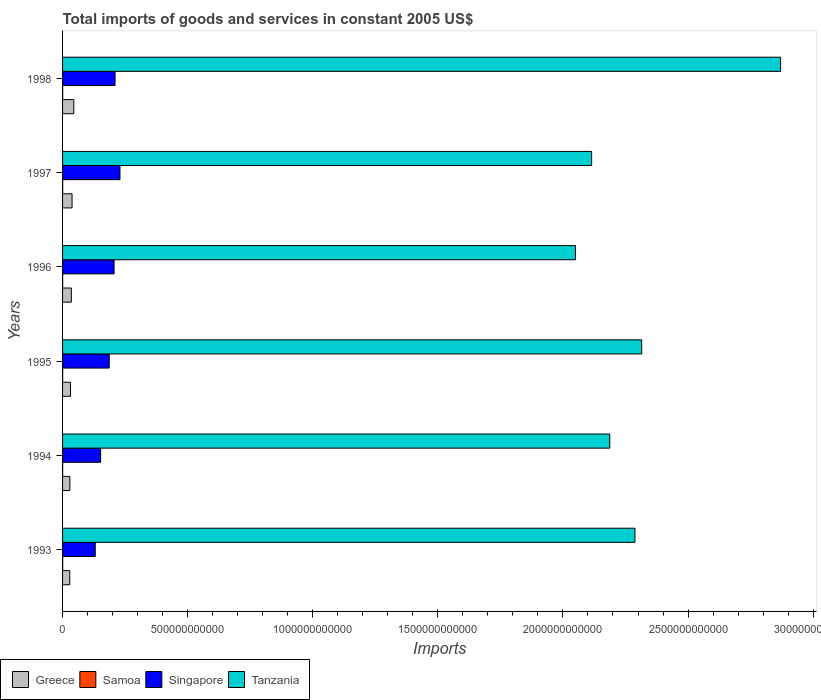How many different coloured bars are there?
Ensure brevity in your answer.  4. How many groups of bars are there?
Ensure brevity in your answer.  6. How many bars are there on the 5th tick from the bottom?
Your answer should be compact. 4. In how many cases, is the number of bars for a given year not equal to the number of legend labels?
Your response must be concise. 0. What is the total imports of goods and services in Greece in 1994?
Your answer should be very brief. 2.92e+1. Across all years, what is the maximum total imports of goods and services in Samoa?
Make the answer very short. 4.44e+08. Across all years, what is the minimum total imports of goods and services in Greece?
Your answer should be compact. 2.88e+1. What is the total total imports of goods and services in Singapore in the graph?
Your answer should be compact. 1.11e+12. What is the difference between the total imports of goods and services in Tanzania in 1993 and that in 1998?
Keep it short and to the point. -5.82e+11. What is the difference between the total imports of goods and services in Tanzania in 1995 and the total imports of goods and services in Greece in 1997?
Make the answer very short. 2.28e+12. What is the average total imports of goods and services in Tanzania per year?
Offer a very short reply. 2.30e+12. In the year 1994, what is the difference between the total imports of goods and services in Samoa and total imports of goods and services in Tanzania?
Your answer should be very brief. -2.19e+12. What is the ratio of the total imports of goods and services in Singapore in 1993 to that in 1996?
Keep it short and to the point. 0.63. Is the total imports of goods and services in Tanzania in 1996 less than that in 1998?
Your answer should be very brief. Yes. What is the difference between the highest and the second highest total imports of goods and services in Greece?
Your answer should be very brief. 6.90e+09. What is the difference between the highest and the lowest total imports of goods and services in Singapore?
Provide a short and direct response. 9.89e+1. In how many years, is the total imports of goods and services in Singapore greater than the average total imports of goods and services in Singapore taken over all years?
Offer a terse response. 4. Is it the case that in every year, the sum of the total imports of goods and services in Samoa and total imports of goods and services in Tanzania is greater than the sum of total imports of goods and services in Greece and total imports of goods and services in Singapore?
Offer a terse response. No. What does the 3rd bar from the bottom in 1995 represents?
Your response must be concise. Singapore. Is it the case that in every year, the sum of the total imports of goods and services in Singapore and total imports of goods and services in Tanzania is greater than the total imports of goods and services in Greece?
Provide a succinct answer. Yes. How many bars are there?
Your response must be concise. 24. How many years are there in the graph?
Your answer should be compact. 6. What is the difference between two consecutive major ticks on the X-axis?
Offer a terse response. 5.00e+11. Does the graph contain any zero values?
Offer a terse response. No. How many legend labels are there?
Provide a short and direct response. 4. How are the legend labels stacked?
Ensure brevity in your answer.  Horizontal. What is the title of the graph?
Offer a terse response. Total imports of goods and services in constant 2005 US$. What is the label or title of the X-axis?
Offer a terse response. Imports. What is the label or title of the Y-axis?
Your answer should be very brief. Years. What is the Imports in Greece in 1993?
Provide a succinct answer. 2.88e+1. What is the Imports in Samoa in 1993?
Keep it short and to the point. 4.41e+08. What is the Imports in Singapore in 1993?
Keep it short and to the point. 1.31e+11. What is the Imports of Tanzania in 1993?
Offer a terse response. 2.29e+12. What is the Imports in Greece in 1994?
Make the answer very short. 2.92e+1. What is the Imports of Samoa in 1994?
Provide a succinct answer. 2.93e+08. What is the Imports of Singapore in 1994?
Offer a terse response. 1.52e+11. What is the Imports of Tanzania in 1994?
Give a very brief answer. 2.19e+12. What is the Imports of Greece in 1995?
Your response must be concise. 3.19e+1. What is the Imports of Samoa in 1995?
Your response must be concise. 3.54e+08. What is the Imports of Singapore in 1995?
Give a very brief answer. 1.87e+11. What is the Imports of Tanzania in 1995?
Your response must be concise. 2.31e+12. What is the Imports in Greece in 1996?
Keep it short and to the point. 3.50e+1. What is the Imports in Samoa in 1996?
Keep it short and to the point. 3.75e+08. What is the Imports in Singapore in 1996?
Make the answer very short. 2.06e+11. What is the Imports of Tanzania in 1996?
Your answer should be compact. 2.05e+12. What is the Imports of Greece in 1997?
Give a very brief answer. 3.80e+1. What is the Imports of Samoa in 1997?
Keep it short and to the point. 3.98e+08. What is the Imports in Singapore in 1997?
Provide a short and direct response. 2.30e+11. What is the Imports in Tanzania in 1997?
Offer a terse response. 2.11e+12. What is the Imports in Greece in 1998?
Give a very brief answer. 4.49e+1. What is the Imports of Samoa in 1998?
Make the answer very short. 4.44e+08. What is the Imports of Singapore in 1998?
Ensure brevity in your answer.  2.10e+11. What is the Imports in Tanzania in 1998?
Your response must be concise. 2.87e+12. Across all years, what is the maximum Imports in Greece?
Offer a very short reply. 4.49e+1. Across all years, what is the maximum Imports in Samoa?
Your answer should be very brief. 4.44e+08. Across all years, what is the maximum Imports of Singapore?
Your response must be concise. 2.30e+11. Across all years, what is the maximum Imports in Tanzania?
Ensure brevity in your answer.  2.87e+12. Across all years, what is the minimum Imports in Greece?
Your answer should be compact. 2.88e+1. Across all years, what is the minimum Imports in Samoa?
Provide a short and direct response. 2.93e+08. Across all years, what is the minimum Imports in Singapore?
Make the answer very short. 1.31e+11. Across all years, what is the minimum Imports of Tanzania?
Give a very brief answer. 2.05e+12. What is the total Imports in Greece in the graph?
Give a very brief answer. 2.08e+11. What is the total Imports in Samoa in the graph?
Ensure brevity in your answer.  2.30e+09. What is the total Imports in Singapore in the graph?
Provide a succinct answer. 1.11e+12. What is the total Imports in Tanzania in the graph?
Your answer should be very brief. 1.38e+13. What is the difference between the Imports in Greece in 1993 and that in 1994?
Offer a very short reply. -4.32e+08. What is the difference between the Imports in Samoa in 1993 and that in 1994?
Keep it short and to the point. 1.48e+08. What is the difference between the Imports of Singapore in 1993 and that in 1994?
Make the answer very short. -2.15e+1. What is the difference between the Imports of Tanzania in 1993 and that in 1994?
Your answer should be very brief. 1.01e+11. What is the difference between the Imports of Greece in 1993 and that in 1995?
Offer a terse response. -3.05e+09. What is the difference between the Imports in Samoa in 1993 and that in 1995?
Give a very brief answer. 8.76e+07. What is the difference between the Imports of Singapore in 1993 and that in 1995?
Keep it short and to the point. -5.59e+1. What is the difference between the Imports of Tanzania in 1993 and that in 1995?
Your answer should be compact. -2.69e+1. What is the difference between the Imports of Greece in 1993 and that in 1996?
Your answer should be compact. -6.21e+09. What is the difference between the Imports of Samoa in 1993 and that in 1996?
Ensure brevity in your answer.  6.65e+07. What is the difference between the Imports of Singapore in 1993 and that in 1996?
Give a very brief answer. -7.53e+1. What is the difference between the Imports of Tanzania in 1993 and that in 1996?
Ensure brevity in your answer.  2.38e+11. What is the difference between the Imports of Greece in 1993 and that in 1997?
Your response must be concise. -9.17e+09. What is the difference between the Imports of Samoa in 1993 and that in 1997?
Make the answer very short. 4.33e+07. What is the difference between the Imports of Singapore in 1993 and that in 1997?
Offer a terse response. -9.89e+1. What is the difference between the Imports of Tanzania in 1993 and that in 1997?
Give a very brief answer. 1.73e+11. What is the difference between the Imports in Greece in 1993 and that in 1998?
Make the answer very short. -1.61e+1. What is the difference between the Imports in Samoa in 1993 and that in 1998?
Offer a terse response. -2.34e+06. What is the difference between the Imports in Singapore in 1993 and that in 1998?
Offer a terse response. -7.92e+1. What is the difference between the Imports of Tanzania in 1993 and that in 1998?
Your answer should be very brief. -5.82e+11. What is the difference between the Imports of Greece in 1994 and that in 1995?
Provide a short and direct response. -2.62e+09. What is the difference between the Imports of Samoa in 1994 and that in 1995?
Provide a succinct answer. -6.03e+07. What is the difference between the Imports of Singapore in 1994 and that in 1995?
Offer a terse response. -3.44e+1. What is the difference between the Imports of Tanzania in 1994 and that in 1995?
Provide a succinct answer. -1.27e+11. What is the difference between the Imports of Greece in 1994 and that in 1996?
Ensure brevity in your answer.  -5.78e+09. What is the difference between the Imports in Samoa in 1994 and that in 1996?
Make the answer very short. -8.14e+07. What is the difference between the Imports of Singapore in 1994 and that in 1996?
Provide a succinct answer. -5.38e+1. What is the difference between the Imports in Tanzania in 1994 and that in 1996?
Provide a succinct answer. 1.37e+11. What is the difference between the Imports of Greece in 1994 and that in 1997?
Offer a terse response. -8.74e+09. What is the difference between the Imports in Samoa in 1994 and that in 1997?
Make the answer very short. -1.05e+08. What is the difference between the Imports of Singapore in 1994 and that in 1997?
Your response must be concise. -7.74e+1. What is the difference between the Imports in Tanzania in 1994 and that in 1997?
Ensure brevity in your answer.  7.25e+1. What is the difference between the Imports in Greece in 1994 and that in 1998?
Offer a terse response. -1.56e+1. What is the difference between the Imports in Samoa in 1994 and that in 1998?
Your answer should be very brief. -1.50e+08. What is the difference between the Imports of Singapore in 1994 and that in 1998?
Provide a succinct answer. -5.77e+1. What is the difference between the Imports of Tanzania in 1994 and that in 1998?
Keep it short and to the point. -6.83e+11. What is the difference between the Imports of Greece in 1995 and that in 1996?
Offer a very short reply. -3.17e+09. What is the difference between the Imports of Samoa in 1995 and that in 1996?
Provide a succinct answer. -2.11e+07. What is the difference between the Imports of Singapore in 1995 and that in 1996?
Your response must be concise. -1.94e+1. What is the difference between the Imports in Tanzania in 1995 and that in 1996?
Provide a succinct answer. 2.65e+11. What is the difference between the Imports of Greece in 1995 and that in 1997?
Offer a very short reply. -6.12e+09. What is the difference between the Imports of Samoa in 1995 and that in 1997?
Your response must be concise. -4.42e+07. What is the difference between the Imports of Singapore in 1995 and that in 1997?
Keep it short and to the point. -4.30e+1. What is the difference between the Imports in Tanzania in 1995 and that in 1997?
Your response must be concise. 2.00e+11. What is the difference between the Imports of Greece in 1995 and that in 1998?
Provide a short and direct response. -1.30e+1. What is the difference between the Imports of Samoa in 1995 and that in 1998?
Offer a terse response. -8.99e+07. What is the difference between the Imports in Singapore in 1995 and that in 1998?
Make the answer very short. -2.33e+1. What is the difference between the Imports in Tanzania in 1995 and that in 1998?
Keep it short and to the point. -5.55e+11. What is the difference between the Imports in Greece in 1996 and that in 1997?
Offer a terse response. -2.96e+09. What is the difference between the Imports in Samoa in 1996 and that in 1997?
Offer a terse response. -2.32e+07. What is the difference between the Imports in Singapore in 1996 and that in 1997?
Offer a very short reply. -2.36e+1. What is the difference between the Imports of Tanzania in 1996 and that in 1997?
Provide a short and direct response. -6.46e+1. What is the difference between the Imports in Greece in 1996 and that in 1998?
Your answer should be compact. -9.85e+09. What is the difference between the Imports of Samoa in 1996 and that in 1998?
Your answer should be very brief. -6.88e+07. What is the difference between the Imports of Singapore in 1996 and that in 1998?
Ensure brevity in your answer.  -3.88e+09. What is the difference between the Imports of Tanzania in 1996 and that in 1998?
Ensure brevity in your answer.  -8.20e+11. What is the difference between the Imports of Greece in 1997 and that in 1998?
Provide a short and direct response. -6.90e+09. What is the difference between the Imports of Samoa in 1997 and that in 1998?
Give a very brief answer. -4.57e+07. What is the difference between the Imports of Singapore in 1997 and that in 1998?
Your answer should be very brief. 1.97e+1. What is the difference between the Imports of Tanzania in 1997 and that in 1998?
Ensure brevity in your answer.  -7.55e+11. What is the difference between the Imports in Greece in 1993 and the Imports in Samoa in 1994?
Offer a terse response. 2.85e+1. What is the difference between the Imports in Greece in 1993 and the Imports in Singapore in 1994?
Provide a succinct answer. -1.23e+11. What is the difference between the Imports in Greece in 1993 and the Imports in Tanzania in 1994?
Your answer should be very brief. -2.16e+12. What is the difference between the Imports in Samoa in 1993 and the Imports in Singapore in 1994?
Make the answer very short. -1.52e+11. What is the difference between the Imports of Samoa in 1993 and the Imports of Tanzania in 1994?
Your response must be concise. -2.19e+12. What is the difference between the Imports in Singapore in 1993 and the Imports in Tanzania in 1994?
Make the answer very short. -2.06e+12. What is the difference between the Imports in Greece in 1993 and the Imports in Samoa in 1995?
Make the answer very short. 2.85e+1. What is the difference between the Imports in Greece in 1993 and the Imports in Singapore in 1995?
Give a very brief answer. -1.58e+11. What is the difference between the Imports in Greece in 1993 and the Imports in Tanzania in 1995?
Make the answer very short. -2.29e+12. What is the difference between the Imports of Samoa in 1993 and the Imports of Singapore in 1995?
Offer a very short reply. -1.86e+11. What is the difference between the Imports in Samoa in 1993 and the Imports in Tanzania in 1995?
Your response must be concise. -2.31e+12. What is the difference between the Imports of Singapore in 1993 and the Imports of Tanzania in 1995?
Your answer should be compact. -2.18e+12. What is the difference between the Imports of Greece in 1993 and the Imports of Samoa in 1996?
Provide a short and direct response. 2.84e+1. What is the difference between the Imports in Greece in 1993 and the Imports in Singapore in 1996?
Ensure brevity in your answer.  -1.77e+11. What is the difference between the Imports in Greece in 1993 and the Imports in Tanzania in 1996?
Ensure brevity in your answer.  -2.02e+12. What is the difference between the Imports of Samoa in 1993 and the Imports of Singapore in 1996?
Keep it short and to the point. -2.06e+11. What is the difference between the Imports in Samoa in 1993 and the Imports in Tanzania in 1996?
Keep it short and to the point. -2.05e+12. What is the difference between the Imports of Singapore in 1993 and the Imports of Tanzania in 1996?
Offer a very short reply. -1.92e+12. What is the difference between the Imports of Greece in 1993 and the Imports of Samoa in 1997?
Make the answer very short. 2.84e+1. What is the difference between the Imports of Greece in 1993 and the Imports of Singapore in 1997?
Provide a short and direct response. -2.01e+11. What is the difference between the Imports in Greece in 1993 and the Imports in Tanzania in 1997?
Provide a succinct answer. -2.09e+12. What is the difference between the Imports in Samoa in 1993 and the Imports in Singapore in 1997?
Ensure brevity in your answer.  -2.29e+11. What is the difference between the Imports of Samoa in 1993 and the Imports of Tanzania in 1997?
Give a very brief answer. -2.11e+12. What is the difference between the Imports of Singapore in 1993 and the Imports of Tanzania in 1997?
Give a very brief answer. -1.98e+12. What is the difference between the Imports of Greece in 1993 and the Imports of Samoa in 1998?
Your answer should be very brief. 2.84e+1. What is the difference between the Imports in Greece in 1993 and the Imports in Singapore in 1998?
Keep it short and to the point. -1.81e+11. What is the difference between the Imports in Greece in 1993 and the Imports in Tanzania in 1998?
Offer a very short reply. -2.84e+12. What is the difference between the Imports of Samoa in 1993 and the Imports of Singapore in 1998?
Offer a very short reply. -2.09e+11. What is the difference between the Imports of Samoa in 1993 and the Imports of Tanzania in 1998?
Ensure brevity in your answer.  -2.87e+12. What is the difference between the Imports in Singapore in 1993 and the Imports in Tanzania in 1998?
Provide a succinct answer. -2.74e+12. What is the difference between the Imports in Greece in 1994 and the Imports in Samoa in 1995?
Your response must be concise. 2.89e+1. What is the difference between the Imports of Greece in 1994 and the Imports of Singapore in 1995?
Offer a terse response. -1.57e+11. What is the difference between the Imports of Greece in 1994 and the Imports of Tanzania in 1995?
Provide a short and direct response. -2.29e+12. What is the difference between the Imports of Samoa in 1994 and the Imports of Singapore in 1995?
Provide a succinct answer. -1.86e+11. What is the difference between the Imports of Samoa in 1994 and the Imports of Tanzania in 1995?
Your response must be concise. -2.31e+12. What is the difference between the Imports in Singapore in 1994 and the Imports in Tanzania in 1995?
Your response must be concise. -2.16e+12. What is the difference between the Imports in Greece in 1994 and the Imports in Samoa in 1996?
Your response must be concise. 2.89e+1. What is the difference between the Imports in Greece in 1994 and the Imports in Singapore in 1996?
Keep it short and to the point. -1.77e+11. What is the difference between the Imports in Greece in 1994 and the Imports in Tanzania in 1996?
Give a very brief answer. -2.02e+12. What is the difference between the Imports in Samoa in 1994 and the Imports in Singapore in 1996?
Keep it short and to the point. -2.06e+11. What is the difference between the Imports of Samoa in 1994 and the Imports of Tanzania in 1996?
Provide a short and direct response. -2.05e+12. What is the difference between the Imports in Singapore in 1994 and the Imports in Tanzania in 1996?
Offer a terse response. -1.90e+12. What is the difference between the Imports of Greece in 1994 and the Imports of Samoa in 1997?
Offer a very short reply. 2.88e+1. What is the difference between the Imports of Greece in 1994 and the Imports of Singapore in 1997?
Provide a succinct answer. -2.00e+11. What is the difference between the Imports of Greece in 1994 and the Imports of Tanzania in 1997?
Offer a very short reply. -2.09e+12. What is the difference between the Imports in Samoa in 1994 and the Imports in Singapore in 1997?
Your response must be concise. -2.29e+11. What is the difference between the Imports of Samoa in 1994 and the Imports of Tanzania in 1997?
Your answer should be compact. -2.11e+12. What is the difference between the Imports of Singapore in 1994 and the Imports of Tanzania in 1997?
Provide a succinct answer. -1.96e+12. What is the difference between the Imports in Greece in 1994 and the Imports in Samoa in 1998?
Give a very brief answer. 2.88e+1. What is the difference between the Imports of Greece in 1994 and the Imports of Singapore in 1998?
Your response must be concise. -1.81e+11. What is the difference between the Imports of Greece in 1994 and the Imports of Tanzania in 1998?
Your response must be concise. -2.84e+12. What is the difference between the Imports in Samoa in 1994 and the Imports in Singapore in 1998?
Ensure brevity in your answer.  -2.10e+11. What is the difference between the Imports in Samoa in 1994 and the Imports in Tanzania in 1998?
Give a very brief answer. -2.87e+12. What is the difference between the Imports in Singapore in 1994 and the Imports in Tanzania in 1998?
Provide a short and direct response. -2.72e+12. What is the difference between the Imports in Greece in 1995 and the Imports in Samoa in 1996?
Your response must be concise. 3.15e+1. What is the difference between the Imports of Greece in 1995 and the Imports of Singapore in 1996?
Offer a terse response. -1.74e+11. What is the difference between the Imports of Greece in 1995 and the Imports of Tanzania in 1996?
Provide a short and direct response. -2.02e+12. What is the difference between the Imports in Samoa in 1995 and the Imports in Singapore in 1996?
Your response must be concise. -2.06e+11. What is the difference between the Imports in Samoa in 1995 and the Imports in Tanzania in 1996?
Your answer should be compact. -2.05e+12. What is the difference between the Imports of Singapore in 1995 and the Imports of Tanzania in 1996?
Ensure brevity in your answer.  -1.86e+12. What is the difference between the Imports of Greece in 1995 and the Imports of Samoa in 1997?
Your response must be concise. 3.15e+1. What is the difference between the Imports in Greece in 1995 and the Imports in Singapore in 1997?
Make the answer very short. -1.98e+11. What is the difference between the Imports in Greece in 1995 and the Imports in Tanzania in 1997?
Your response must be concise. -2.08e+12. What is the difference between the Imports in Samoa in 1995 and the Imports in Singapore in 1997?
Give a very brief answer. -2.29e+11. What is the difference between the Imports of Samoa in 1995 and the Imports of Tanzania in 1997?
Your response must be concise. -2.11e+12. What is the difference between the Imports in Singapore in 1995 and the Imports in Tanzania in 1997?
Your response must be concise. -1.93e+12. What is the difference between the Imports of Greece in 1995 and the Imports of Samoa in 1998?
Offer a very short reply. 3.14e+1. What is the difference between the Imports in Greece in 1995 and the Imports in Singapore in 1998?
Make the answer very short. -1.78e+11. What is the difference between the Imports of Greece in 1995 and the Imports of Tanzania in 1998?
Keep it short and to the point. -2.84e+12. What is the difference between the Imports of Samoa in 1995 and the Imports of Singapore in 1998?
Provide a succinct answer. -2.09e+11. What is the difference between the Imports in Samoa in 1995 and the Imports in Tanzania in 1998?
Offer a terse response. -2.87e+12. What is the difference between the Imports in Singapore in 1995 and the Imports in Tanzania in 1998?
Keep it short and to the point. -2.68e+12. What is the difference between the Imports of Greece in 1996 and the Imports of Samoa in 1997?
Provide a succinct answer. 3.46e+1. What is the difference between the Imports of Greece in 1996 and the Imports of Singapore in 1997?
Provide a succinct answer. -1.94e+11. What is the difference between the Imports in Greece in 1996 and the Imports in Tanzania in 1997?
Keep it short and to the point. -2.08e+12. What is the difference between the Imports in Samoa in 1996 and the Imports in Singapore in 1997?
Ensure brevity in your answer.  -2.29e+11. What is the difference between the Imports of Samoa in 1996 and the Imports of Tanzania in 1997?
Your answer should be very brief. -2.11e+12. What is the difference between the Imports of Singapore in 1996 and the Imports of Tanzania in 1997?
Keep it short and to the point. -1.91e+12. What is the difference between the Imports of Greece in 1996 and the Imports of Samoa in 1998?
Give a very brief answer. 3.46e+1. What is the difference between the Imports in Greece in 1996 and the Imports in Singapore in 1998?
Offer a very short reply. -1.75e+11. What is the difference between the Imports of Greece in 1996 and the Imports of Tanzania in 1998?
Keep it short and to the point. -2.83e+12. What is the difference between the Imports of Samoa in 1996 and the Imports of Singapore in 1998?
Give a very brief answer. -2.09e+11. What is the difference between the Imports of Samoa in 1996 and the Imports of Tanzania in 1998?
Your answer should be very brief. -2.87e+12. What is the difference between the Imports in Singapore in 1996 and the Imports in Tanzania in 1998?
Offer a terse response. -2.66e+12. What is the difference between the Imports of Greece in 1997 and the Imports of Samoa in 1998?
Give a very brief answer. 3.75e+1. What is the difference between the Imports of Greece in 1997 and the Imports of Singapore in 1998?
Give a very brief answer. -1.72e+11. What is the difference between the Imports in Greece in 1997 and the Imports in Tanzania in 1998?
Your answer should be compact. -2.83e+12. What is the difference between the Imports of Samoa in 1997 and the Imports of Singapore in 1998?
Your response must be concise. -2.09e+11. What is the difference between the Imports in Samoa in 1997 and the Imports in Tanzania in 1998?
Offer a very short reply. -2.87e+12. What is the difference between the Imports in Singapore in 1997 and the Imports in Tanzania in 1998?
Ensure brevity in your answer.  -2.64e+12. What is the average Imports in Greece per year?
Your answer should be very brief. 3.46e+1. What is the average Imports in Samoa per year?
Your response must be concise. 3.84e+08. What is the average Imports in Singapore per year?
Offer a very short reply. 1.86e+11. What is the average Imports in Tanzania per year?
Give a very brief answer. 2.30e+12. In the year 1993, what is the difference between the Imports of Greece and Imports of Samoa?
Your response must be concise. 2.84e+1. In the year 1993, what is the difference between the Imports of Greece and Imports of Singapore?
Ensure brevity in your answer.  -1.02e+11. In the year 1993, what is the difference between the Imports of Greece and Imports of Tanzania?
Your answer should be compact. -2.26e+12. In the year 1993, what is the difference between the Imports in Samoa and Imports in Singapore?
Ensure brevity in your answer.  -1.30e+11. In the year 1993, what is the difference between the Imports of Samoa and Imports of Tanzania?
Ensure brevity in your answer.  -2.29e+12. In the year 1993, what is the difference between the Imports in Singapore and Imports in Tanzania?
Make the answer very short. -2.16e+12. In the year 1994, what is the difference between the Imports in Greece and Imports in Samoa?
Your answer should be compact. 2.89e+1. In the year 1994, what is the difference between the Imports of Greece and Imports of Singapore?
Offer a terse response. -1.23e+11. In the year 1994, what is the difference between the Imports of Greece and Imports of Tanzania?
Make the answer very short. -2.16e+12. In the year 1994, what is the difference between the Imports of Samoa and Imports of Singapore?
Give a very brief answer. -1.52e+11. In the year 1994, what is the difference between the Imports of Samoa and Imports of Tanzania?
Provide a succinct answer. -2.19e+12. In the year 1994, what is the difference between the Imports of Singapore and Imports of Tanzania?
Your answer should be compact. -2.04e+12. In the year 1995, what is the difference between the Imports in Greece and Imports in Samoa?
Ensure brevity in your answer.  3.15e+1. In the year 1995, what is the difference between the Imports of Greece and Imports of Singapore?
Offer a very short reply. -1.55e+11. In the year 1995, what is the difference between the Imports of Greece and Imports of Tanzania?
Ensure brevity in your answer.  -2.28e+12. In the year 1995, what is the difference between the Imports in Samoa and Imports in Singapore?
Provide a succinct answer. -1.86e+11. In the year 1995, what is the difference between the Imports in Samoa and Imports in Tanzania?
Your response must be concise. -2.31e+12. In the year 1995, what is the difference between the Imports in Singapore and Imports in Tanzania?
Offer a very short reply. -2.13e+12. In the year 1996, what is the difference between the Imports of Greece and Imports of Samoa?
Keep it short and to the point. 3.46e+1. In the year 1996, what is the difference between the Imports of Greece and Imports of Singapore?
Provide a short and direct response. -1.71e+11. In the year 1996, what is the difference between the Imports in Greece and Imports in Tanzania?
Give a very brief answer. -2.02e+12. In the year 1996, what is the difference between the Imports of Samoa and Imports of Singapore?
Offer a terse response. -2.06e+11. In the year 1996, what is the difference between the Imports in Samoa and Imports in Tanzania?
Keep it short and to the point. -2.05e+12. In the year 1996, what is the difference between the Imports in Singapore and Imports in Tanzania?
Provide a succinct answer. -1.84e+12. In the year 1997, what is the difference between the Imports in Greece and Imports in Samoa?
Provide a succinct answer. 3.76e+1. In the year 1997, what is the difference between the Imports in Greece and Imports in Singapore?
Keep it short and to the point. -1.92e+11. In the year 1997, what is the difference between the Imports of Greece and Imports of Tanzania?
Make the answer very short. -2.08e+12. In the year 1997, what is the difference between the Imports of Samoa and Imports of Singapore?
Give a very brief answer. -2.29e+11. In the year 1997, what is the difference between the Imports of Samoa and Imports of Tanzania?
Provide a short and direct response. -2.11e+12. In the year 1997, what is the difference between the Imports of Singapore and Imports of Tanzania?
Offer a very short reply. -1.89e+12. In the year 1998, what is the difference between the Imports in Greece and Imports in Samoa?
Ensure brevity in your answer.  4.44e+1. In the year 1998, what is the difference between the Imports of Greece and Imports of Singapore?
Ensure brevity in your answer.  -1.65e+11. In the year 1998, what is the difference between the Imports of Greece and Imports of Tanzania?
Your answer should be compact. -2.83e+12. In the year 1998, what is the difference between the Imports in Samoa and Imports in Singapore?
Provide a succinct answer. -2.09e+11. In the year 1998, what is the difference between the Imports of Samoa and Imports of Tanzania?
Offer a very short reply. -2.87e+12. In the year 1998, what is the difference between the Imports in Singapore and Imports in Tanzania?
Your answer should be compact. -2.66e+12. What is the ratio of the Imports of Greece in 1993 to that in 1994?
Offer a terse response. 0.99. What is the ratio of the Imports in Samoa in 1993 to that in 1994?
Your answer should be compact. 1.5. What is the ratio of the Imports of Singapore in 1993 to that in 1994?
Your response must be concise. 0.86. What is the ratio of the Imports of Tanzania in 1993 to that in 1994?
Your answer should be compact. 1.05. What is the ratio of the Imports of Greece in 1993 to that in 1995?
Provide a short and direct response. 0.9. What is the ratio of the Imports of Samoa in 1993 to that in 1995?
Offer a very short reply. 1.25. What is the ratio of the Imports of Singapore in 1993 to that in 1995?
Provide a short and direct response. 0.7. What is the ratio of the Imports of Tanzania in 1993 to that in 1995?
Ensure brevity in your answer.  0.99. What is the ratio of the Imports of Greece in 1993 to that in 1996?
Give a very brief answer. 0.82. What is the ratio of the Imports in Samoa in 1993 to that in 1996?
Ensure brevity in your answer.  1.18. What is the ratio of the Imports in Singapore in 1993 to that in 1996?
Make the answer very short. 0.63. What is the ratio of the Imports of Tanzania in 1993 to that in 1996?
Offer a terse response. 1.12. What is the ratio of the Imports of Greece in 1993 to that in 1997?
Offer a very short reply. 0.76. What is the ratio of the Imports in Samoa in 1993 to that in 1997?
Your response must be concise. 1.11. What is the ratio of the Imports of Singapore in 1993 to that in 1997?
Your answer should be very brief. 0.57. What is the ratio of the Imports in Tanzania in 1993 to that in 1997?
Your answer should be very brief. 1.08. What is the ratio of the Imports of Greece in 1993 to that in 1998?
Ensure brevity in your answer.  0.64. What is the ratio of the Imports of Singapore in 1993 to that in 1998?
Offer a very short reply. 0.62. What is the ratio of the Imports in Tanzania in 1993 to that in 1998?
Offer a very short reply. 0.8. What is the ratio of the Imports of Greece in 1994 to that in 1995?
Your answer should be compact. 0.92. What is the ratio of the Imports of Samoa in 1994 to that in 1995?
Your answer should be compact. 0.83. What is the ratio of the Imports of Singapore in 1994 to that in 1995?
Make the answer very short. 0.82. What is the ratio of the Imports of Tanzania in 1994 to that in 1995?
Your answer should be compact. 0.94. What is the ratio of the Imports of Greece in 1994 to that in 1996?
Give a very brief answer. 0.83. What is the ratio of the Imports in Samoa in 1994 to that in 1996?
Provide a short and direct response. 0.78. What is the ratio of the Imports of Singapore in 1994 to that in 1996?
Offer a very short reply. 0.74. What is the ratio of the Imports in Tanzania in 1994 to that in 1996?
Your answer should be very brief. 1.07. What is the ratio of the Imports in Greece in 1994 to that in 1997?
Offer a terse response. 0.77. What is the ratio of the Imports of Samoa in 1994 to that in 1997?
Ensure brevity in your answer.  0.74. What is the ratio of the Imports of Singapore in 1994 to that in 1997?
Ensure brevity in your answer.  0.66. What is the ratio of the Imports of Tanzania in 1994 to that in 1997?
Offer a very short reply. 1.03. What is the ratio of the Imports in Greece in 1994 to that in 1998?
Offer a terse response. 0.65. What is the ratio of the Imports of Samoa in 1994 to that in 1998?
Provide a succinct answer. 0.66. What is the ratio of the Imports of Singapore in 1994 to that in 1998?
Ensure brevity in your answer.  0.73. What is the ratio of the Imports of Tanzania in 1994 to that in 1998?
Provide a succinct answer. 0.76. What is the ratio of the Imports in Greece in 1995 to that in 1996?
Your response must be concise. 0.91. What is the ratio of the Imports of Samoa in 1995 to that in 1996?
Your response must be concise. 0.94. What is the ratio of the Imports of Singapore in 1995 to that in 1996?
Keep it short and to the point. 0.91. What is the ratio of the Imports in Tanzania in 1995 to that in 1996?
Offer a very short reply. 1.13. What is the ratio of the Imports of Greece in 1995 to that in 1997?
Your answer should be compact. 0.84. What is the ratio of the Imports in Samoa in 1995 to that in 1997?
Keep it short and to the point. 0.89. What is the ratio of the Imports in Singapore in 1995 to that in 1997?
Your answer should be compact. 0.81. What is the ratio of the Imports of Tanzania in 1995 to that in 1997?
Keep it short and to the point. 1.09. What is the ratio of the Imports of Greece in 1995 to that in 1998?
Give a very brief answer. 0.71. What is the ratio of the Imports in Samoa in 1995 to that in 1998?
Keep it short and to the point. 0.8. What is the ratio of the Imports of Singapore in 1995 to that in 1998?
Your answer should be very brief. 0.89. What is the ratio of the Imports in Tanzania in 1995 to that in 1998?
Give a very brief answer. 0.81. What is the ratio of the Imports of Greece in 1996 to that in 1997?
Ensure brevity in your answer.  0.92. What is the ratio of the Imports in Samoa in 1996 to that in 1997?
Provide a succinct answer. 0.94. What is the ratio of the Imports in Singapore in 1996 to that in 1997?
Give a very brief answer. 0.9. What is the ratio of the Imports in Tanzania in 1996 to that in 1997?
Provide a succinct answer. 0.97. What is the ratio of the Imports of Greece in 1996 to that in 1998?
Your response must be concise. 0.78. What is the ratio of the Imports of Samoa in 1996 to that in 1998?
Your answer should be compact. 0.84. What is the ratio of the Imports of Singapore in 1996 to that in 1998?
Ensure brevity in your answer.  0.98. What is the ratio of the Imports of Tanzania in 1996 to that in 1998?
Offer a terse response. 0.71. What is the ratio of the Imports in Greece in 1997 to that in 1998?
Your answer should be very brief. 0.85. What is the ratio of the Imports of Samoa in 1997 to that in 1998?
Your answer should be very brief. 0.9. What is the ratio of the Imports in Singapore in 1997 to that in 1998?
Your response must be concise. 1.09. What is the ratio of the Imports of Tanzania in 1997 to that in 1998?
Provide a succinct answer. 0.74. What is the difference between the highest and the second highest Imports in Greece?
Your answer should be compact. 6.90e+09. What is the difference between the highest and the second highest Imports in Samoa?
Your response must be concise. 2.34e+06. What is the difference between the highest and the second highest Imports of Singapore?
Give a very brief answer. 1.97e+1. What is the difference between the highest and the second highest Imports in Tanzania?
Your answer should be compact. 5.55e+11. What is the difference between the highest and the lowest Imports in Greece?
Provide a short and direct response. 1.61e+1. What is the difference between the highest and the lowest Imports of Samoa?
Your answer should be compact. 1.50e+08. What is the difference between the highest and the lowest Imports of Singapore?
Your answer should be very brief. 9.89e+1. What is the difference between the highest and the lowest Imports in Tanzania?
Ensure brevity in your answer.  8.20e+11. 